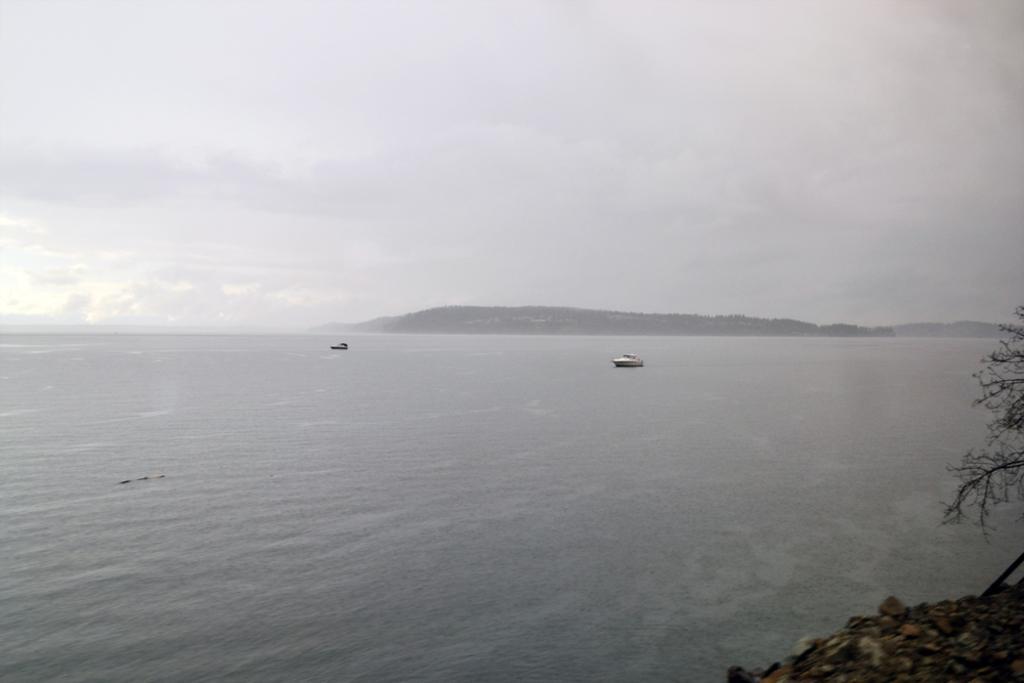In one or two sentences, can you explain what this image depicts? In the center of the image we can see two boats in the water. To the right side of the image we can see a tree. In the background, we can see mountains and sky. 